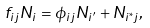<formula> <loc_0><loc_0><loc_500><loc_500>f _ { i j } N _ { i } = \phi _ { i j } N _ { i ^ { \prime } } + N _ { i ^ { * } j } ,</formula> 